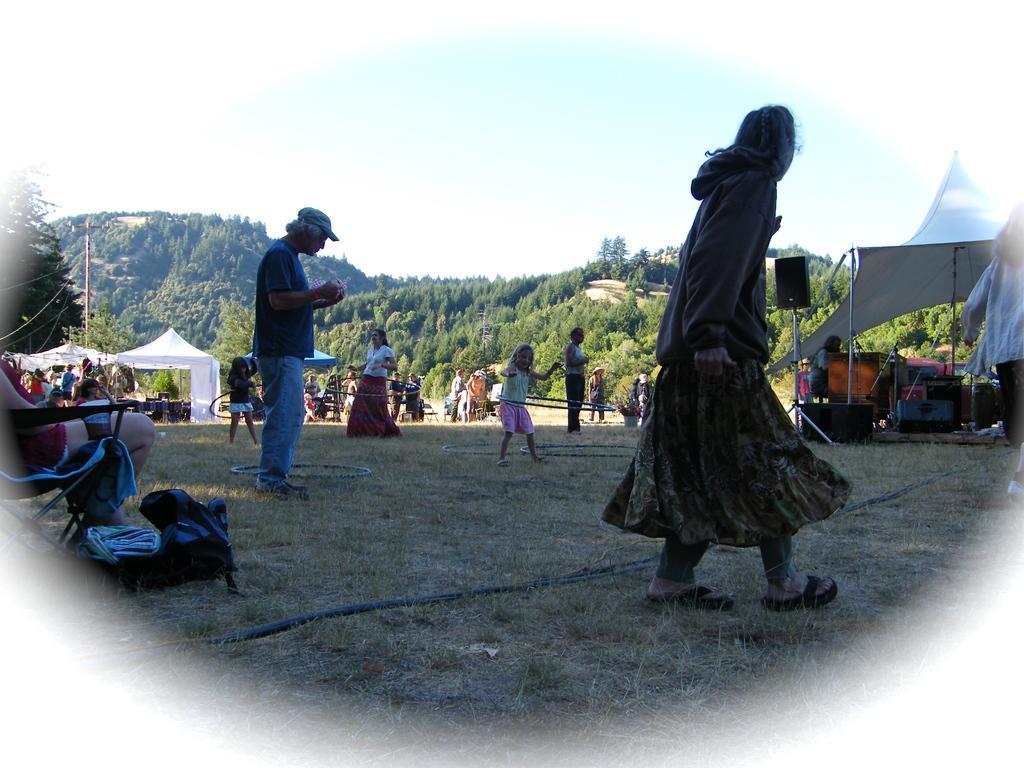Could you give a brief overview of what you see in this image? In this image we can see group of people standing on the ground. Two children are wearing hula hoop. One woman is wearing a white t shirt and red gown. In the background we can see group of sheds, speaker ,poles,trees , mountain,chairs and sky. 